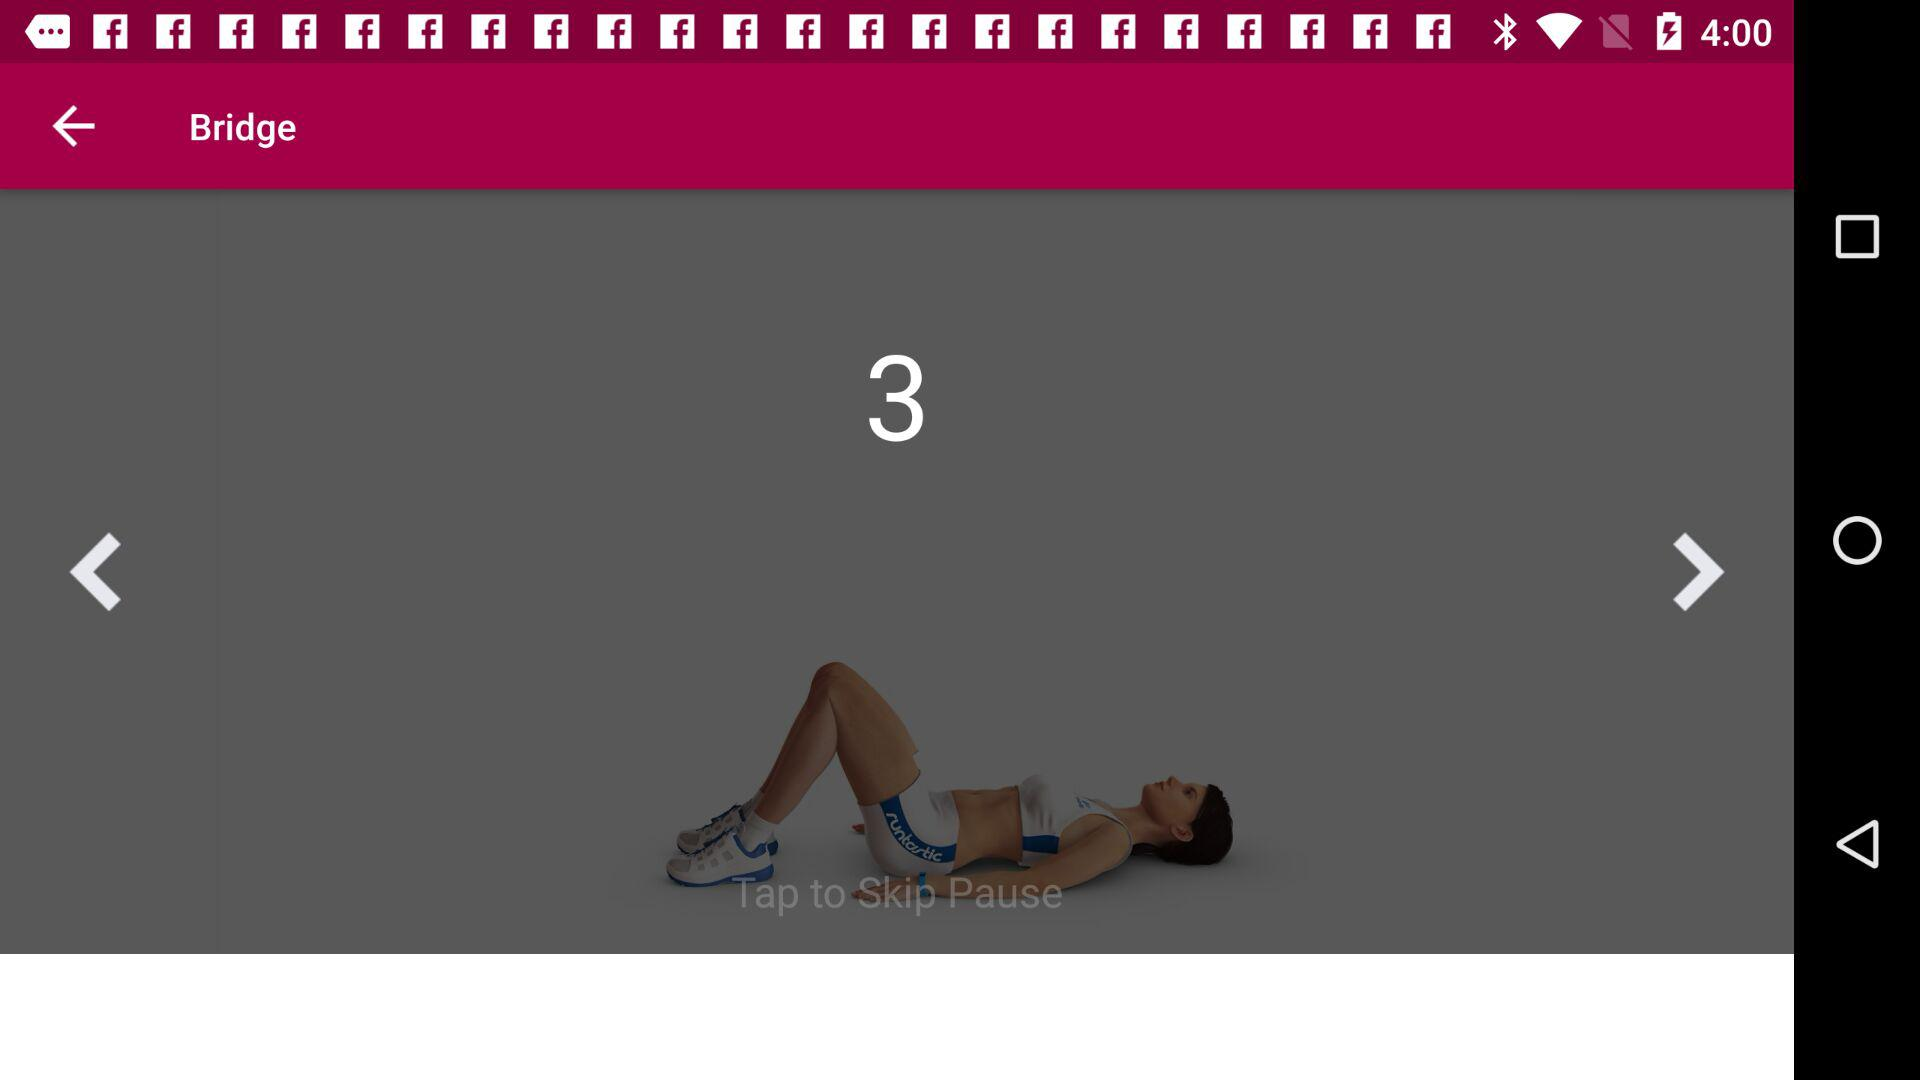How many days in total are there? There are 7 days in total. 